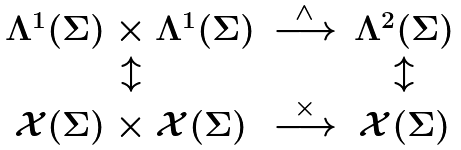Convert formula to latex. <formula><loc_0><loc_0><loc_500><loc_500>\begin{array} { c c c } \Lambda ^ { 1 } ( \Sigma ) \times \Lambda ^ { 1 } ( \Sigma ) & \stackrel { \wedge } { \longrightarrow } & \Lambda ^ { 2 } ( \Sigma ) \\ \updownarrow & & \updownarrow \\ \mathcal { X } ( \Sigma ) \times \mathcal { X } ( \Sigma ) & \stackrel { \times } { \longrightarrow } & \mathcal { X } ( \Sigma ) \end{array}</formula> 